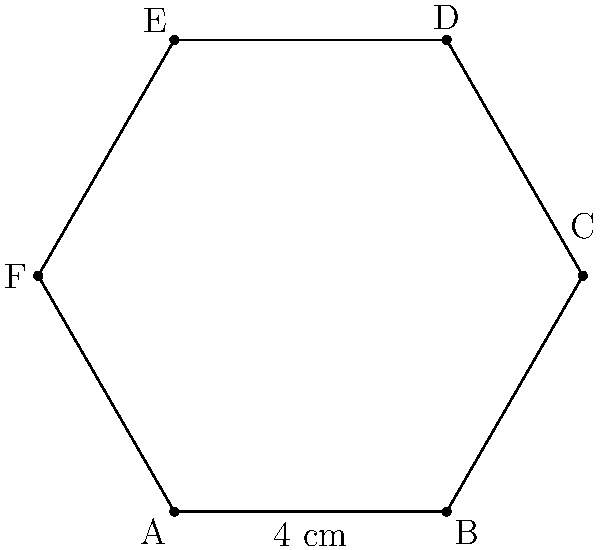A hexagonal risk tolerance chart is used to visualize a client's investment preferences across six different risk factors. Each side of the hexagon represents a risk factor, and the length of each side corresponds to the client's tolerance for that particular risk. If each side of the hexagon measures 4 cm, what is the perimeter of the entire chart? To find the perimeter of the hexagonal risk tolerance chart, we need to follow these steps:

1. Recall the formula for the perimeter of a regular hexagon:
   $$ \text{Perimeter} = 6 \times \text{side length} $$

2. We are given that each side of the hexagon measures 4 cm.

3. Substitute the side length into the formula:
   $$ \text{Perimeter} = 6 \times 4 \text{ cm} $$

4. Perform the multiplication:
   $$ \text{Perimeter} = 24 \text{ cm} $$

Therefore, the perimeter of the hexagonal risk tolerance chart is 24 cm.
Answer: 24 cm 